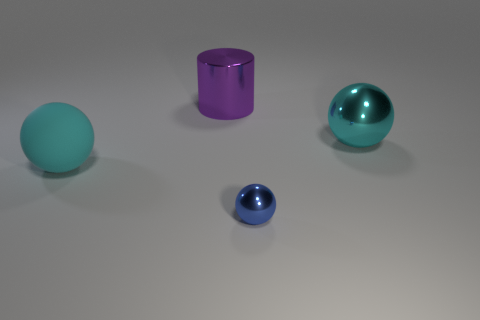Subtract all cyan matte spheres. How many spheres are left? 2 Add 3 red matte blocks. How many objects exist? 7 Subtract all small cyan shiny balls. Subtract all cyan rubber things. How many objects are left? 3 Add 2 large purple metallic cylinders. How many large purple metallic cylinders are left? 3 Add 1 large purple cylinders. How many large purple cylinders exist? 2 Subtract all cyan spheres. How many spheres are left? 1 Subtract 2 cyan balls. How many objects are left? 2 Subtract all balls. How many objects are left? 1 Subtract 2 balls. How many balls are left? 1 Subtract all gray spheres. Subtract all brown cylinders. How many spheres are left? 3 